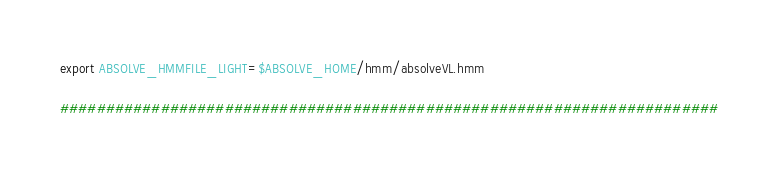Convert code to text. <code><loc_0><loc_0><loc_500><loc_500><_Bash_>export ABSOLVE_HMMFILE_LIGHT=$ABSOLVE_HOME/hmm/absolveVL.hmm

########################################################################


</code> 